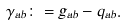Convert formula to latex. <formula><loc_0><loc_0><loc_500><loc_500>\gamma _ { a b } \colon = g _ { a b } - q _ { a b } .</formula> 